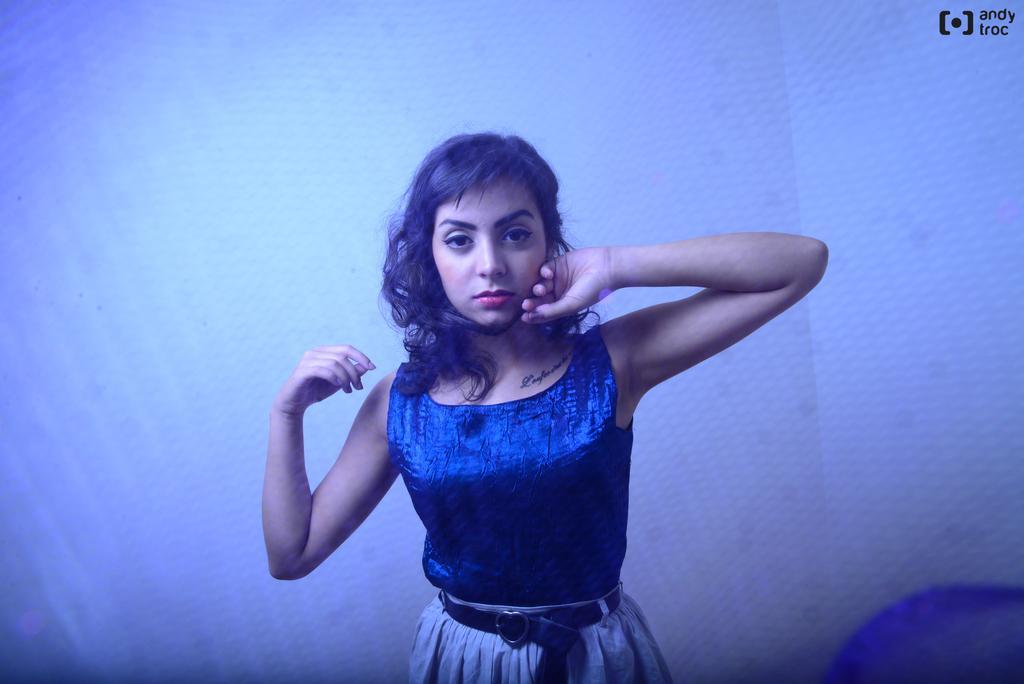Please provide a concise description of this image. In the center of the image we can see a woman wearing the belt and she is having the tattoo. In the background we can see the wall. In the top right corner there is logo with the text. 